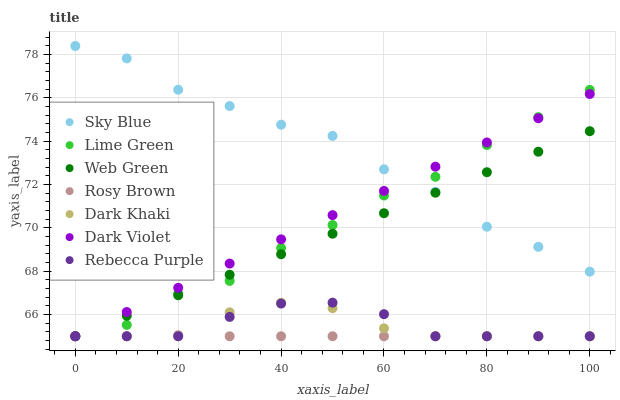Does Rosy Brown have the minimum area under the curve?
Answer yes or no. Yes. Does Sky Blue have the maximum area under the curve?
Answer yes or no. Yes. Does Dark Violet have the minimum area under the curve?
Answer yes or no. No. Does Dark Violet have the maximum area under the curve?
Answer yes or no. No. Is Dark Violet the smoothest?
Answer yes or no. Yes. Is Sky Blue the roughest?
Answer yes or no. Yes. Is Dark Khaki the smoothest?
Answer yes or no. No. Is Dark Khaki the roughest?
Answer yes or no. No. Does Rosy Brown have the lowest value?
Answer yes or no. Yes. Does Sky Blue have the lowest value?
Answer yes or no. No. Does Sky Blue have the highest value?
Answer yes or no. Yes. Does Dark Violet have the highest value?
Answer yes or no. No. Is Rosy Brown less than Sky Blue?
Answer yes or no. Yes. Is Sky Blue greater than Rebecca Purple?
Answer yes or no. Yes. Does Rebecca Purple intersect Dark Khaki?
Answer yes or no. Yes. Is Rebecca Purple less than Dark Khaki?
Answer yes or no. No. Is Rebecca Purple greater than Dark Khaki?
Answer yes or no. No. Does Rosy Brown intersect Sky Blue?
Answer yes or no. No. 